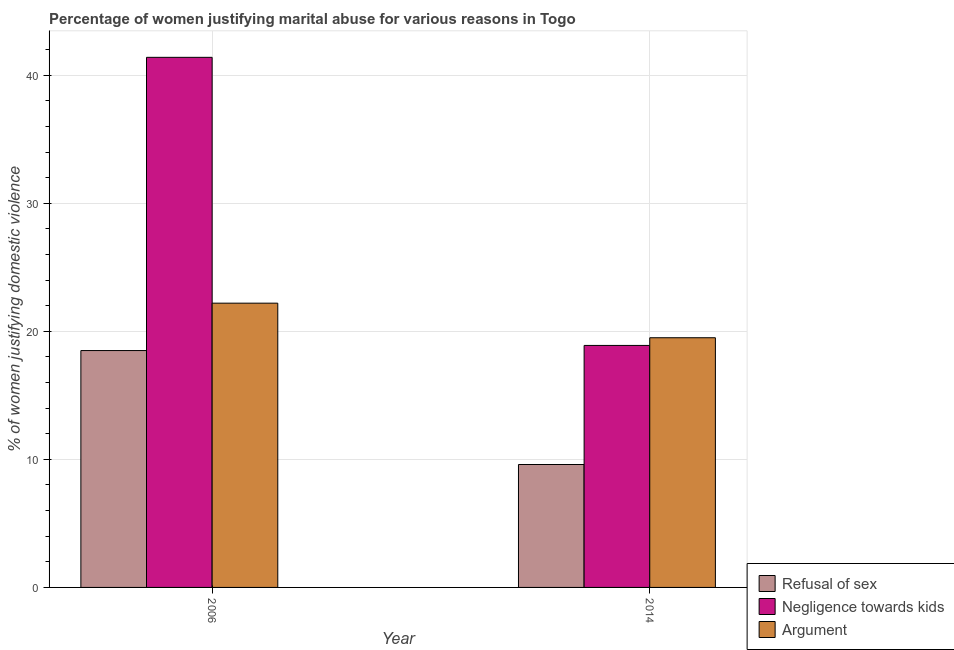How many different coloured bars are there?
Provide a succinct answer. 3. How many groups of bars are there?
Your response must be concise. 2. Are the number of bars on each tick of the X-axis equal?
Ensure brevity in your answer.  Yes. What is the label of the 2nd group of bars from the left?
Offer a very short reply. 2014. In how many cases, is the number of bars for a given year not equal to the number of legend labels?
Provide a short and direct response. 0. Across all years, what is the minimum percentage of women justifying domestic violence due to arguments?
Your answer should be very brief. 19.5. What is the total percentage of women justifying domestic violence due to arguments in the graph?
Ensure brevity in your answer.  41.7. What is the difference between the percentage of women justifying domestic violence due to refusal of sex in 2014 and the percentage of women justifying domestic violence due to negligence towards kids in 2006?
Keep it short and to the point. -8.9. What is the average percentage of women justifying domestic violence due to refusal of sex per year?
Your answer should be very brief. 14.05. In how many years, is the percentage of women justifying domestic violence due to negligence towards kids greater than 10 %?
Make the answer very short. 2. What is the ratio of the percentage of women justifying domestic violence due to refusal of sex in 2006 to that in 2014?
Keep it short and to the point. 1.93. In how many years, is the percentage of women justifying domestic violence due to refusal of sex greater than the average percentage of women justifying domestic violence due to refusal of sex taken over all years?
Offer a very short reply. 1. What does the 2nd bar from the left in 2006 represents?
Make the answer very short. Negligence towards kids. What does the 3rd bar from the right in 2014 represents?
Your response must be concise. Refusal of sex. Is it the case that in every year, the sum of the percentage of women justifying domestic violence due to refusal of sex and percentage of women justifying domestic violence due to negligence towards kids is greater than the percentage of women justifying domestic violence due to arguments?
Provide a succinct answer. Yes. Are all the bars in the graph horizontal?
Provide a short and direct response. No. Does the graph contain any zero values?
Keep it short and to the point. No. Where does the legend appear in the graph?
Give a very brief answer. Bottom right. What is the title of the graph?
Keep it short and to the point. Percentage of women justifying marital abuse for various reasons in Togo. Does "Refusal of sex" appear as one of the legend labels in the graph?
Your answer should be very brief. Yes. What is the label or title of the X-axis?
Give a very brief answer. Year. What is the label or title of the Y-axis?
Provide a short and direct response. % of women justifying domestic violence. What is the % of women justifying domestic violence in Refusal of sex in 2006?
Provide a succinct answer. 18.5. What is the % of women justifying domestic violence of Negligence towards kids in 2006?
Give a very brief answer. 41.4. What is the % of women justifying domestic violence in Refusal of sex in 2014?
Give a very brief answer. 9.6. What is the % of women justifying domestic violence in Argument in 2014?
Your answer should be very brief. 19.5. Across all years, what is the maximum % of women justifying domestic violence of Refusal of sex?
Your answer should be compact. 18.5. Across all years, what is the maximum % of women justifying domestic violence of Negligence towards kids?
Provide a succinct answer. 41.4. Across all years, what is the maximum % of women justifying domestic violence in Argument?
Your answer should be compact. 22.2. Across all years, what is the minimum % of women justifying domestic violence in Refusal of sex?
Keep it short and to the point. 9.6. Across all years, what is the minimum % of women justifying domestic violence in Negligence towards kids?
Give a very brief answer. 18.9. What is the total % of women justifying domestic violence of Refusal of sex in the graph?
Ensure brevity in your answer.  28.1. What is the total % of women justifying domestic violence in Negligence towards kids in the graph?
Your answer should be very brief. 60.3. What is the total % of women justifying domestic violence of Argument in the graph?
Ensure brevity in your answer.  41.7. What is the difference between the % of women justifying domestic violence of Refusal of sex in 2006 and that in 2014?
Offer a very short reply. 8.9. What is the difference between the % of women justifying domestic violence in Negligence towards kids in 2006 and that in 2014?
Provide a short and direct response. 22.5. What is the difference between the % of women justifying domestic violence of Argument in 2006 and that in 2014?
Make the answer very short. 2.7. What is the difference between the % of women justifying domestic violence of Refusal of sex in 2006 and the % of women justifying domestic violence of Negligence towards kids in 2014?
Your answer should be very brief. -0.4. What is the difference between the % of women justifying domestic violence in Negligence towards kids in 2006 and the % of women justifying domestic violence in Argument in 2014?
Your answer should be compact. 21.9. What is the average % of women justifying domestic violence of Refusal of sex per year?
Give a very brief answer. 14.05. What is the average % of women justifying domestic violence of Negligence towards kids per year?
Your answer should be very brief. 30.15. What is the average % of women justifying domestic violence of Argument per year?
Make the answer very short. 20.85. In the year 2006, what is the difference between the % of women justifying domestic violence of Refusal of sex and % of women justifying domestic violence of Negligence towards kids?
Provide a short and direct response. -22.9. In the year 2006, what is the difference between the % of women justifying domestic violence in Refusal of sex and % of women justifying domestic violence in Argument?
Give a very brief answer. -3.7. In the year 2006, what is the difference between the % of women justifying domestic violence in Negligence towards kids and % of women justifying domestic violence in Argument?
Make the answer very short. 19.2. In the year 2014, what is the difference between the % of women justifying domestic violence in Refusal of sex and % of women justifying domestic violence in Argument?
Your answer should be compact. -9.9. What is the ratio of the % of women justifying domestic violence in Refusal of sex in 2006 to that in 2014?
Your answer should be compact. 1.93. What is the ratio of the % of women justifying domestic violence in Negligence towards kids in 2006 to that in 2014?
Ensure brevity in your answer.  2.19. What is the ratio of the % of women justifying domestic violence of Argument in 2006 to that in 2014?
Keep it short and to the point. 1.14. What is the difference between the highest and the second highest % of women justifying domestic violence of Argument?
Offer a very short reply. 2.7. What is the difference between the highest and the lowest % of women justifying domestic violence in Refusal of sex?
Your response must be concise. 8.9. 